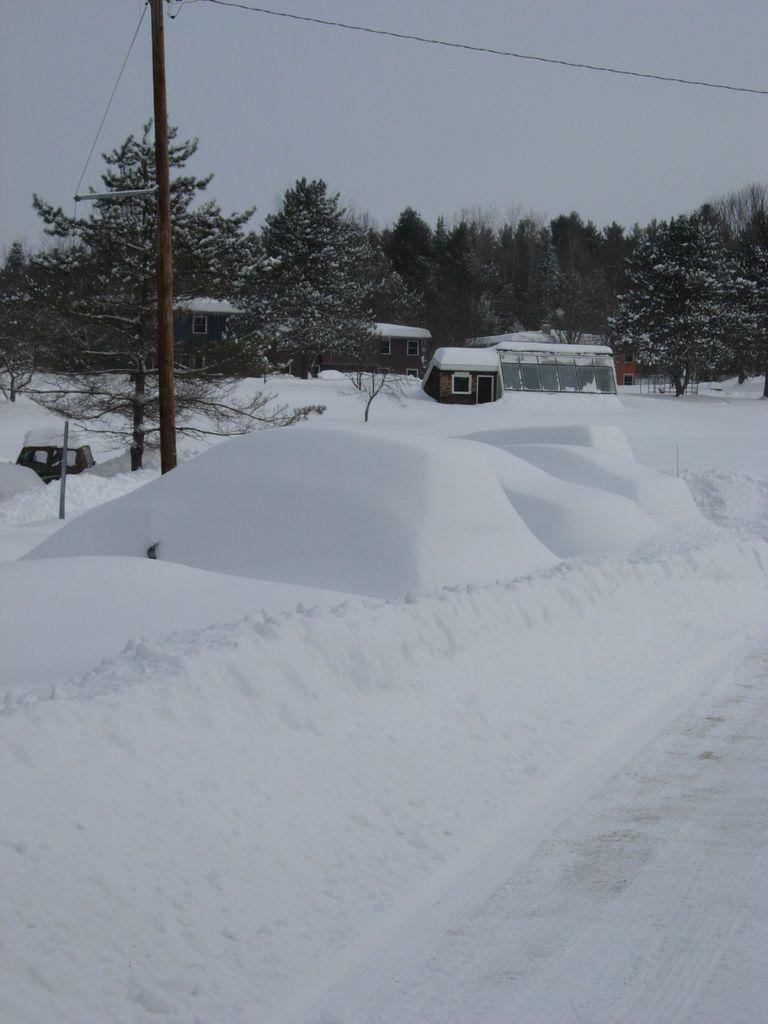What type of vegetation can be seen in the image? There are trees in the image. What type of structures are present in the image? There are houses in the image. What are the tall, thin objects in the image? There are poles in the image. What is covering the ground in the image? There is snow in the image. What can be seen in the background of the image? The sky is visible in the background of the image. What type of rhythm can be heard in the image? There is no sound or rhythm present in the image, as it is a still photograph. Is there a watch visible on any of the trees in the image? There is no watch present in the image; only trees, houses, poles, snow, and the sky are visible. 